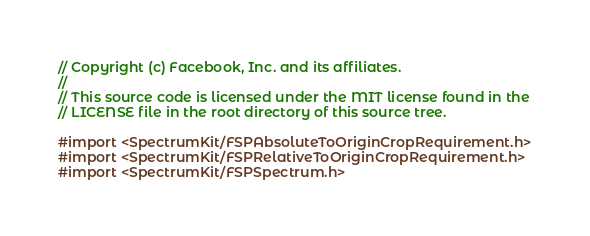<code> <loc_0><loc_0><loc_500><loc_500><_C_>// Copyright (c) Facebook, Inc. and its affiliates.
//
// This source code is licensed under the MIT license found in the
// LICENSE file in the root directory of this source tree.

#import <SpectrumKit/FSPAbsoluteToOriginCropRequirement.h>
#import <SpectrumKit/FSPRelativeToOriginCropRequirement.h>
#import <SpectrumKit/FSPSpectrum.h>
</code> 